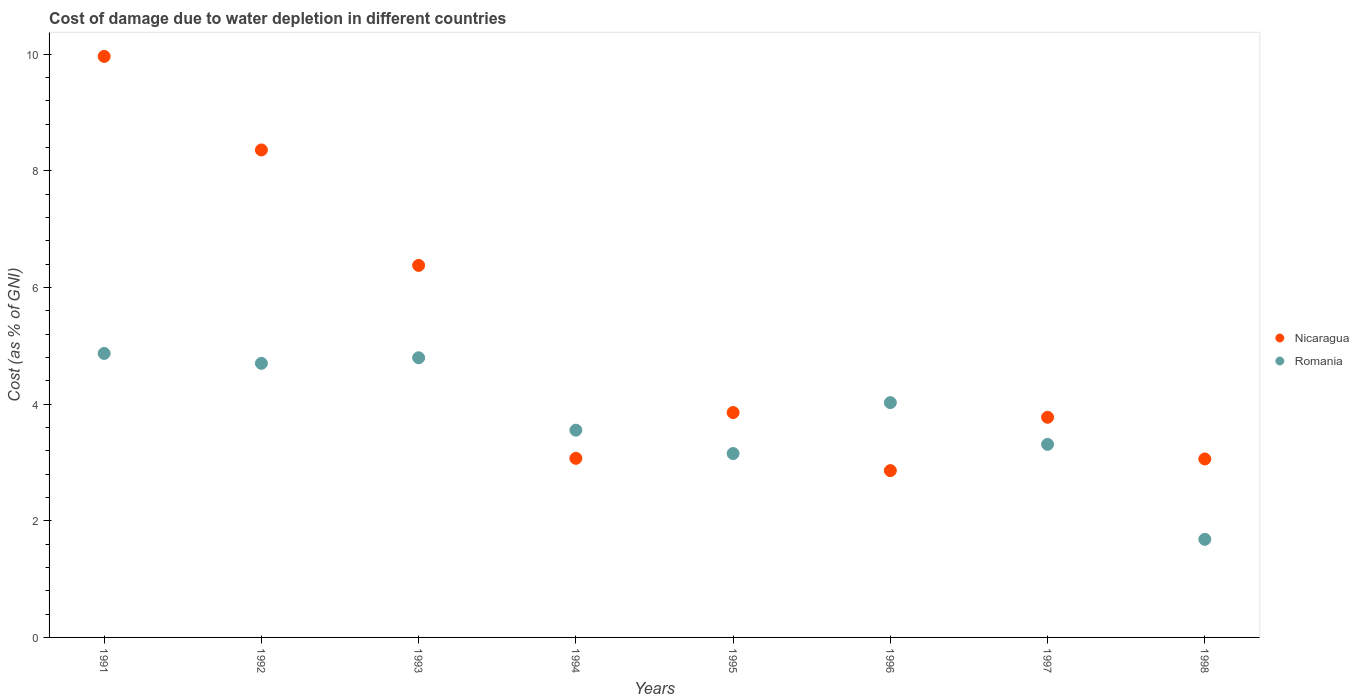How many different coloured dotlines are there?
Make the answer very short. 2. What is the cost of damage caused due to water depletion in Romania in 1994?
Give a very brief answer. 3.55. Across all years, what is the maximum cost of damage caused due to water depletion in Nicaragua?
Offer a very short reply. 9.96. Across all years, what is the minimum cost of damage caused due to water depletion in Nicaragua?
Ensure brevity in your answer.  2.86. What is the total cost of damage caused due to water depletion in Nicaragua in the graph?
Make the answer very short. 41.33. What is the difference between the cost of damage caused due to water depletion in Nicaragua in 1992 and that in 1997?
Your answer should be compact. 4.58. What is the difference between the cost of damage caused due to water depletion in Romania in 1993 and the cost of damage caused due to water depletion in Nicaragua in 1994?
Your response must be concise. 1.72. What is the average cost of damage caused due to water depletion in Nicaragua per year?
Your response must be concise. 5.17. In the year 1993, what is the difference between the cost of damage caused due to water depletion in Romania and cost of damage caused due to water depletion in Nicaragua?
Provide a short and direct response. -1.58. In how many years, is the cost of damage caused due to water depletion in Romania greater than 9.6 %?
Offer a very short reply. 0. What is the ratio of the cost of damage caused due to water depletion in Romania in 1992 to that in 1995?
Your answer should be compact. 1.49. Is the cost of damage caused due to water depletion in Nicaragua in 1992 less than that in 1996?
Provide a short and direct response. No. What is the difference between the highest and the second highest cost of damage caused due to water depletion in Nicaragua?
Make the answer very short. 1.6. What is the difference between the highest and the lowest cost of damage caused due to water depletion in Romania?
Offer a very short reply. 3.19. Is the cost of damage caused due to water depletion in Romania strictly less than the cost of damage caused due to water depletion in Nicaragua over the years?
Offer a terse response. No. What is the difference between two consecutive major ticks on the Y-axis?
Your response must be concise. 2. Does the graph contain any zero values?
Ensure brevity in your answer.  No. Does the graph contain grids?
Provide a short and direct response. No. Where does the legend appear in the graph?
Provide a short and direct response. Center right. How are the legend labels stacked?
Ensure brevity in your answer.  Vertical. What is the title of the graph?
Provide a short and direct response. Cost of damage due to water depletion in different countries. Does "Belgium" appear as one of the legend labels in the graph?
Offer a very short reply. No. What is the label or title of the Y-axis?
Provide a short and direct response. Cost (as % of GNI). What is the Cost (as % of GNI) in Nicaragua in 1991?
Offer a terse response. 9.96. What is the Cost (as % of GNI) in Romania in 1991?
Keep it short and to the point. 4.87. What is the Cost (as % of GNI) in Nicaragua in 1992?
Your answer should be compact. 8.36. What is the Cost (as % of GNI) of Romania in 1992?
Keep it short and to the point. 4.7. What is the Cost (as % of GNI) in Nicaragua in 1993?
Provide a succinct answer. 6.38. What is the Cost (as % of GNI) in Romania in 1993?
Make the answer very short. 4.8. What is the Cost (as % of GNI) in Nicaragua in 1994?
Give a very brief answer. 3.07. What is the Cost (as % of GNI) of Romania in 1994?
Make the answer very short. 3.55. What is the Cost (as % of GNI) of Nicaragua in 1995?
Ensure brevity in your answer.  3.86. What is the Cost (as % of GNI) in Romania in 1995?
Your answer should be very brief. 3.15. What is the Cost (as % of GNI) of Nicaragua in 1996?
Your answer should be very brief. 2.86. What is the Cost (as % of GNI) of Romania in 1996?
Offer a terse response. 4.03. What is the Cost (as % of GNI) in Nicaragua in 1997?
Ensure brevity in your answer.  3.78. What is the Cost (as % of GNI) in Romania in 1997?
Your answer should be compact. 3.31. What is the Cost (as % of GNI) of Nicaragua in 1998?
Your answer should be compact. 3.06. What is the Cost (as % of GNI) in Romania in 1998?
Your answer should be very brief. 1.68. Across all years, what is the maximum Cost (as % of GNI) of Nicaragua?
Your answer should be compact. 9.96. Across all years, what is the maximum Cost (as % of GNI) of Romania?
Provide a short and direct response. 4.87. Across all years, what is the minimum Cost (as % of GNI) in Nicaragua?
Your answer should be very brief. 2.86. Across all years, what is the minimum Cost (as % of GNI) of Romania?
Provide a succinct answer. 1.68. What is the total Cost (as % of GNI) in Nicaragua in the graph?
Make the answer very short. 41.33. What is the total Cost (as % of GNI) in Romania in the graph?
Provide a succinct answer. 30.09. What is the difference between the Cost (as % of GNI) of Nicaragua in 1991 and that in 1992?
Offer a very short reply. 1.6. What is the difference between the Cost (as % of GNI) in Romania in 1991 and that in 1992?
Give a very brief answer. 0.17. What is the difference between the Cost (as % of GNI) of Nicaragua in 1991 and that in 1993?
Make the answer very short. 3.58. What is the difference between the Cost (as % of GNI) in Romania in 1991 and that in 1993?
Give a very brief answer. 0.07. What is the difference between the Cost (as % of GNI) of Nicaragua in 1991 and that in 1994?
Your response must be concise. 6.89. What is the difference between the Cost (as % of GNI) in Romania in 1991 and that in 1994?
Offer a terse response. 1.32. What is the difference between the Cost (as % of GNI) in Nicaragua in 1991 and that in 1995?
Your answer should be very brief. 6.11. What is the difference between the Cost (as % of GNI) in Romania in 1991 and that in 1995?
Offer a terse response. 1.72. What is the difference between the Cost (as % of GNI) in Nicaragua in 1991 and that in 1996?
Your response must be concise. 7.1. What is the difference between the Cost (as % of GNI) in Romania in 1991 and that in 1996?
Your answer should be very brief. 0.84. What is the difference between the Cost (as % of GNI) in Nicaragua in 1991 and that in 1997?
Make the answer very short. 6.19. What is the difference between the Cost (as % of GNI) in Romania in 1991 and that in 1997?
Make the answer very short. 1.56. What is the difference between the Cost (as % of GNI) in Nicaragua in 1991 and that in 1998?
Provide a succinct answer. 6.9. What is the difference between the Cost (as % of GNI) of Romania in 1991 and that in 1998?
Your answer should be compact. 3.19. What is the difference between the Cost (as % of GNI) in Nicaragua in 1992 and that in 1993?
Your response must be concise. 1.98. What is the difference between the Cost (as % of GNI) in Romania in 1992 and that in 1993?
Keep it short and to the point. -0.1. What is the difference between the Cost (as % of GNI) in Nicaragua in 1992 and that in 1994?
Give a very brief answer. 5.29. What is the difference between the Cost (as % of GNI) of Romania in 1992 and that in 1994?
Ensure brevity in your answer.  1.15. What is the difference between the Cost (as % of GNI) of Nicaragua in 1992 and that in 1995?
Keep it short and to the point. 4.5. What is the difference between the Cost (as % of GNI) in Romania in 1992 and that in 1995?
Keep it short and to the point. 1.55. What is the difference between the Cost (as % of GNI) in Nicaragua in 1992 and that in 1996?
Give a very brief answer. 5.5. What is the difference between the Cost (as % of GNI) of Romania in 1992 and that in 1996?
Provide a succinct answer. 0.67. What is the difference between the Cost (as % of GNI) in Nicaragua in 1992 and that in 1997?
Your answer should be very brief. 4.58. What is the difference between the Cost (as % of GNI) in Romania in 1992 and that in 1997?
Give a very brief answer. 1.39. What is the difference between the Cost (as % of GNI) in Nicaragua in 1992 and that in 1998?
Ensure brevity in your answer.  5.3. What is the difference between the Cost (as % of GNI) in Romania in 1992 and that in 1998?
Provide a short and direct response. 3.02. What is the difference between the Cost (as % of GNI) in Nicaragua in 1993 and that in 1994?
Your answer should be compact. 3.31. What is the difference between the Cost (as % of GNI) in Romania in 1993 and that in 1994?
Provide a short and direct response. 1.24. What is the difference between the Cost (as % of GNI) in Nicaragua in 1993 and that in 1995?
Your answer should be very brief. 2.52. What is the difference between the Cost (as % of GNI) in Romania in 1993 and that in 1995?
Offer a terse response. 1.64. What is the difference between the Cost (as % of GNI) in Nicaragua in 1993 and that in 1996?
Provide a succinct answer. 3.52. What is the difference between the Cost (as % of GNI) in Romania in 1993 and that in 1996?
Give a very brief answer. 0.77. What is the difference between the Cost (as % of GNI) in Nicaragua in 1993 and that in 1997?
Ensure brevity in your answer.  2.6. What is the difference between the Cost (as % of GNI) of Romania in 1993 and that in 1997?
Your answer should be compact. 1.49. What is the difference between the Cost (as % of GNI) of Nicaragua in 1993 and that in 1998?
Give a very brief answer. 3.32. What is the difference between the Cost (as % of GNI) in Romania in 1993 and that in 1998?
Provide a succinct answer. 3.11. What is the difference between the Cost (as % of GNI) in Nicaragua in 1994 and that in 1995?
Offer a very short reply. -0.79. What is the difference between the Cost (as % of GNI) in Romania in 1994 and that in 1995?
Offer a terse response. 0.4. What is the difference between the Cost (as % of GNI) in Nicaragua in 1994 and that in 1996?
Provide a short and direct response. 0.21. What is the difference between the Cost (as % of GNI) in Romania in 1994 and that in 1996?
Offer a very short reply. -0.47. What is the difference between the Cost (as % of GNI) in Nicaragua in 1994 and that in 1997?
Provide a short and direct response. -0.7. What is the difference between the Cost (as % of GNI) in Romania in 1994 and that in 1997?
Provide a short and direct response. 0.24. What is the difference between the Cost (as % of GNI) in Nicaragua in 1994 and that in 1998?
Make the answer very short. 0.01. What is the difference between the Cost (as % of GNI) in Romania in 1994 and that in 1998?
Provide a short and direct response. 1.87. What is the difference between the Cost (as % of GNI) of Romania in 1995 and that in 1996?
Provide a short and direct response. -0.87. What is the difference between the Cost (as % of GNI) in Nicaragua in 1995 and that in 1997?
Your answer should be compact. 0.08. What is the difference between the Cost (as % of GNI) of Romania in 1995 and that in 1997?
Your response must be concise. -0.16. What is the difference between the Cost (as % of GNI) of Nicaragua in 1995 and that in 1998?
Your response must be concise. 0.8. What is the difference between the Cost (as % of GNI) of Romania in 1995 and that in 1998?
Provide a succinct answer. 1.47. What is the difference between the Cost (as % of GNI) in Nicaragua in 1996 and that in 1997?
Offer a terse response. -0.91. What is the difference between the Cost (as % of GNI) of Romania in 1996 and that in 1997?
Offer a terse response. 0.72. What is the difference between the Cost (as % of GNI) in Nicaragua in 1996 and that in 1998?
Offer a terse response. -0.2. What is the difference between the Cost (as % of GNI) in Romania in 1996 and that in 1998?
Offer a very short reply. 2.34. What is the difference between the Cost (as % of GNI) of Nicaragua in 1997 and that in 1998?
Your answer should be compact. 0.71. What is the difference between the Cost (as % of GNI) of Romania in 1997 and that in 1998?
Your response must be concise. 1.63. What is the difference between the Cost (as % of GNI) in Nicaragua in 1991 and the Cost (as % of GNI) in Romania in 1992?
Offer a very short reply. 5.26. What is the difference between the Cost (as % of GNI) in Nicaragua in 1991 and the Cost (as % of GNI) in Romania in 1993?
Offer a terse response. 5.17. What is the difference between the Cost (as % of GNI) of Nicaragua in 1991 and the Cost (as % of GNI) of Romania in 1994?
Provide a short and direct response. 6.41. What is the difference between the Cost (as % of GNI) of Nicaragua in 1991 and the Cost (as % of GNI) of Romania in 1995?
Give a very brief answer. 6.81. What is the difference between the Cost (as % of GNI) of Nicaragua in 1991 and the Cost (as % of GNI) of Romania in 1996?
Keep it short and to the point. 5.94. What is the difference between the Cost (as % of GNI) in Nicaragua in 1991 and the Cost (as % of GNI) in Romania in 1997?
Your response must be concise. 6.65. What is the difference between the Cost (as % of GNI) in Nicaragua in 1991 and the Cost (as % of GNI) in Romania in 1998?
Offer a very short reply. 8.28. What is the difference between the Cost (as % of GNI) of Nicaragua in 1992 and the Cost (as % of GNI) of Romania in 1993?
Offer a very short reply. 3.56. What is the difference between the Cost (as % of GNI) in Nicaragua in 1992 and the Cost (as % of GNI) in Romania in 1994?
Provide a short and direct response. 4.81. What is the difference between the Cost (as % of GNI) in Nicaragua in 1992 and the Cost (as % of GNI) in Romania in 1995?
Offer a terse response. 5.21. What is the difference between the Cost (as % of GNI) of Nicaragua in 1992 and the Cost (as % of GNI) of Romania in 1996?
Give a very brief answer. 4.33. What is the difference between the Cost (as % of GNI) in Nicaragua in 1992 and the Cost (as % of GNI) in Romania in 1997?
Your answer should be compact. 5.05. What is the difference between the Cost (as % of GNI) of Nicaragua in 1992 and the Cost (as % of GNI) of Romania in 1998?
Your answer should be very brief. 6.68. What is the difference between the Cost (as % of GNI) of Nicaragua in 1993 and the Cost (as % of GNI) of Romania in 1994?
Offer a terse response. 2.83. What is the difference between the Cost (as % of GNI) of Nicaragua in 1993 and the Cost (as % of GNI) of Romania in 1995?
Offer a terse response. 3.23. What is the difference between the Cost (as % of GNI) in Nicaragua in 1993 and the Cost (as % of GNI) in Romania in 1996?
Offer a very short reply. 2.35. What is the difference between the Cost (as % of GNI) in Nicaragua in 1993 and the Cost (as % of GNI) in Romania in 1997?
Your answer should be compact. 3.07. What is the difference between the Cost (as % of GNI) of Nicaragua in 1993 and the Cost (as % of GNI) of Romania in 1998?
Provide a succinct answer. 4.7. What is the difference between the Cost (as % of GNI) in Nicaragua in 1994 and the Cost (as % of GNI) in Romania in 1995?
Ensure brevity in your answer.  -0.08. What is the difference between the Cost (as % of GNI) of Nicaragua in 1994 and the Cost (as % of GNI) of Romania in 1996?
Provide a short and direct response. -0.96. What is the difference between the Cost (as % of GNI) of Nicaragua in 1994 and the Cost (as % of GNI) of Romania in 1997?
Your response must be concise. -0.24. What is the difference between the Cost (as % of GNI) in Nicaragua in 1994 and the Cost (as % of GNI) in Romania in 1998?
Offer a very short reply. 1.39. What is the difference between the Cost (as % of GNI) of Nicaragua in 1995 and the Cost (as % of GNI) of Romania in 1996?
Ensure brevity in your answer.  -0.17. What is the difference between the Cost (as % of GNI) of Nicaragua in 1995 and the Cost (as % of GNI) of Romania in 1997?
Your answer should be compact. 0.55. What is the difference between the Cost (as % of GNI) in Nicaragua in 1995 and the Cost (as % of GNI) in Romania in 1998?
Offer a very short reply. 2.17. What is the difference between the Cost (as % of GNI) in Nicaragua in 1996 and the Cost (as % of GNI) in Romania in 1997?
Make the answer very short. -0.45. What is the difference between the Cost (as % of GNI) of Nicaragua in 1996 and the Cost (as % of GNI) of Romania in 1998?
Make the answer very short. 1.18. What is the difference between the Cost (as % of GNI) in Nicaragua in 1997 and the Cost (as % of GNI) in Romania in 1998?
Provide a succinct answer. 2.09. What is the average Cost (as % of GNI) in Nicaragua per year?
Make the answer very short. 5.17. What is the average Cost (as % of GNI) in Romania per year?
Keep it short and to the point. 3.76. In the year 1991, what is the difference between the Cost (as % of GNI) of Nicaragua and Cost (as % of GNI) of Romania?
Offer a terse response. 5.09. In the year 1992, what is the difference between the Cost (as % of GNI) in Nicaragua and Cost (as % of GNI) in Romania?
Provide a short and direct response. 3.66. In the year 1993, what is the difference between the Cost (as % of GNI) in Nicaragua and Cost (as % of GNI) in Romania?
Give a very brief answer. 1.58. In the year 1994, what is the difference between the Cost (as % of GNI) in Nicaragua and Cost (as % of GNI) in Romania?
Ensure brevity in your answer.  -0.48. In the year 1995, what is the difference between the Cost (as % of GNI) of Nicaragua and Cost (as % of GNI) of Romania?
Provide a short and direct response. 0.7. In the year 1996, what is the difference between the Cost (as % of GNI) of Nicaragua and Cost (as % of GNI) of Romania?
Provide a succinct answer. -1.17. In the year 1997, what is the difference between the Cost (as % of GNI) in Nicaragua and Cost (as % of GNI) in Romania?
Provide a succinct answer. 0.46. In the year 1998, what is the difference between the Cost (as % of GNI) in Nicaragua and Cost (as % of GNI) in Romania?
Offer a very short reply. 1.38. What is the ratio of the Cost (as % of GNI) of Nicaragua in 1991 to that in 1992?
Offer a very short reply. 1.19. What is the ratio of the Cost (as % of GNI) of Romania in 1991 to that in 1992?
Offer a terse response. 1.04. What is the ratio of the Cost (as % of GNI) of Nicaragua in 1991 to that in 1993?
Ensure brevity in your answer.  1.56. What is the ratio of the Cost (as % of GNI) in Romania in 1991 to that in 1993?
Offer a terse response. 1.02. What is the ratio of the Cost (as % of GNI) in Nicaragua in 1991 to that in 1994?
Give a very brief answer. 3.24. What is the ratio of the Cost (as % of GNI) of Romania in 1991 to that in 1994?
Give a very brief answer. 1.37. What is the ratio of the Cost (as % of GNI) in Nicaragua in 1991 to that in 1995?
Ensure brevity in your answer.  2.58. What is the ratio of the Cost (as % of GNI) of Romania in 1991 to that in 1995?
Give a very brief answer. 1.54. What is the ratio of the Cost (as % of GNI) in Nicaragua in 1991 to that in 1996?
Ensure brevity in your answer.  3.48. What is the ratio of the Cost (as % of GNI) in Romania in 1991 to that in 1996?
Provide a short and direct response. 1.21. What is the ratio of the Cost (as % of GNI) in Nicaragua in 1991 to that in 1997?
Offer a very short reply. 2.64. What is the ratio of the Cost (as % of GNI) in Romania in 1991 to that in 1997?
Provide a succinct answer. 1.47. What is the ratio of the Cost (as % of GNI) of Nicaragua in 1991 to that in 1998?
Make the answer very short. 3.26. What is the ratio of the Cost (as % of GNI) of Romania in 1991 to that in 1998?
Make the answer very short. 2.89. What is the ratio of the Cost (as % of GNI) in Nicaragua in 1992 to that in 1993?
Ensure brevity in your answer.  1.31. What is the ratio of the Cost (as % of GNI) of Romania in 1992 to that in 1993?
Provide a succinct answer. 0.98. What is the ratio of the Cost (as % of GNI) in Nicaragua in 1992 to that in 1994?
Make the answer very short. 2.72. What is the ratio of the Cost (as % of GNI) of Romania in 1992 to that in 1994?
Offer a very short reply. 1.32. What is the ratio of the Cost (as % of GNI) of Nicaragua in 1992 to that in 1995?
Offer a terse response. 2.17. What is the ratio of the Cost (as % of GNI) in Romania in 1992 to that in 1995?
Your answer should be very brief. 1.49. What is the ratio of the Cost (as % of GNI) in Nicaragua in 1992 to that in 1996?
Your response must be concise. 2.92. What is the ratio of the Cost (as % of GNI) of Romania in 1992 to that in 1996?
Make the answer very short. 1.17. What is the ratio of the Cost (as % of GNI) of Nicaragua in 1992 to that in 1997?
Keep it short and to the point. 2.21. What is the ratio of the Cost (as % of GNI) of Romania in 1992 to that in 1997?
Give a very brief answer. 1.42. What is the ratio of the Cost (as % of GNI) in Nicaragua in 1992 to that in 1998?
Keep it short and to the point. 2.73. What is the ratio of the Cost (as % of GNI) in Romania in 1992 to that in 1998?
Offer a terse response. 2.79. What is the ratio of the Cost (as % of GNI) in Nicaragua in 1993 to that in 1994?
Provide a short and direct response. 2.08. What is the ratio of the Cost (as % of GNI) of Romania in 1993 to that in 1994?
Give a very brief answer. 1.35. What is the ratio of the Cost (as % of GNI) in Nicaragua in 1993 to that in 1995?
Provide a succinct answer. 1.65. What is the ratio of the Cost (as % of GNI) in Romania in 1993 to that in 1995?
Give a very brief answer. 1.52. What is the ratio of the Cost (as % of GNI) of Nicaragua in 1993 to that in 1996?
Give a very brief answer. 2.23. What is the ratio of the Cost (as % of GNI) of Romania in 1993 to that in 1996?
Offer a terse response. 1.19. What is the ratio of the Cost (as % of GNI) of Nicaragua in 1993 to that in 1997?
Give a very brief answer. 1.69. What is the ratio of the Cost (as % of GNI) in Romania in 1993 to that in 1997?
Keep it short and to the point. 1.45. What is the ratio of the Cost (as % of GNI) of Nicaragua in 1993 to that in 1998?
Keep it short and to the point. 2.08. What is the ratio of the Cost (as % of GNI) in Romania in 1993 to that in 1998?
Your response must be concise. 2.85. What is the ratio of the Cost (as % of GNI) in Nicaragua in 1994 to that in 1995?
Your answer should be very brief. 0.8. What is the ratio of the Cost (as % of GNI) of Romania in 1994 to that in 1995?
Your answer should be very brief. 1.13. What is the ratio of the Cost (as % of GNI) in Nicaragua in 1994 to that in 1996?
Your response must be concise. 1.07. What is the ratio of the Cost (as % of GNI) of Romania in 1994 to that in 1996?
Provide a short and direct response. 0.88. What is the ratio of the Cost (as % of GNI) of Nicaragua in 1994 to that in 1997?
Make the answer very short. 0.81. What is the ratio of the Cost (as % of GNI) of Romania in 1994 to that in 1997?
Offer a very short reply. 1.07. What is the ratio of the Cost (as % of GNI) of Romania in 1994 to that in 1998?
Offer a very short reply. 2.11. What is the ratio of the Cost (as % of GNI) of Nicaragua in 1995 to that in 1996?
Provide a short and direct response. 1.35. What is the ratio of the Cost (as % of GNI) in Romania in 1995 to that in 1996?
Keep it short and to the point. 0.78. What is the ratio of the Cost (as % of GNI) of Nicaragua in 1995 to that in 1997?
Your answer should be very brief. 1.02. What is the ratio of the Cost (as % of GNI) in Romania in 1995 to that in 1997?
Keep it short and to the point. 0.95. What is the ratio of the Cost (as % of GNI) of Nicaragua in 1995 to that in 1998?
Ensure brevity in your answer.  1.26. What is the ratio of the Cost (as % of GNI) of Romania in 1995 to that in 1998?
Make the answer very short. 1.87. What is the ratio of the Cost (as % of GNI) of Nicaragua in 1996 to that in 1997?
Offer a very short reply. 0.76. What is the ratio of the Cost (as % of GNI) of Romania in 1996 to that in 1997?
Provide a succinct answer. 1.22. What is the ratio of the Cost (as % of GNI) in Nicaragua in 1996 to that in 1998?
Keep it short and to the point. 0.93. What is the ratio of the Cost (as % of GNI) in Romania in 1996 to that in 1998?
Provide a succinct answer. 2.39. What is the ratio of the Cost (as % of GNI) of Nicaragua in 1997 to that in 1998?
Your answer should be compact. 1.23. What is the ratio of the Cost (as % of GNI) of Romania in 1997 to that in 1998?
Your answer should be very brief. 1.97. What is the difference between the highest and the second highest Cost (as % of GNI) in Nicaragua?
Ensure brevity in your answer.  1.6. What is the difference between the highest and the second highest Cost (as % of GNI) in Romania?
Ensure brevity in your answer.  0.07. What is the difference between the highest and the lowest Cost (as % of GNI) of Nicaragua?
Provide a short and direct response. 7.1. What is the difference between the highest and the lowest Cost (as % of GNI) in Romania?
Make the answer very short. 3.19. 